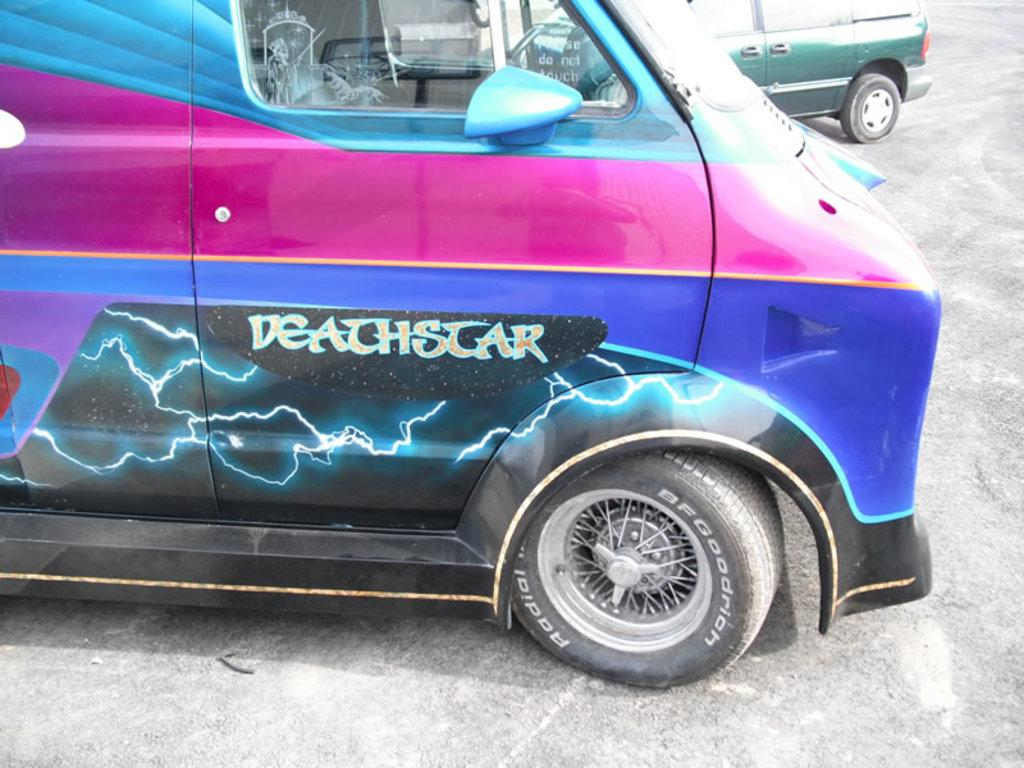What can be seen on the road in the image? There are vehicles on the road in the image. Can you describe any specific details about the vehicles? There is text visible on a car door in the image. Where is the bat sitting on the throne in the image? There is no bat or throne present in the image; it only features vehicles on the road. 